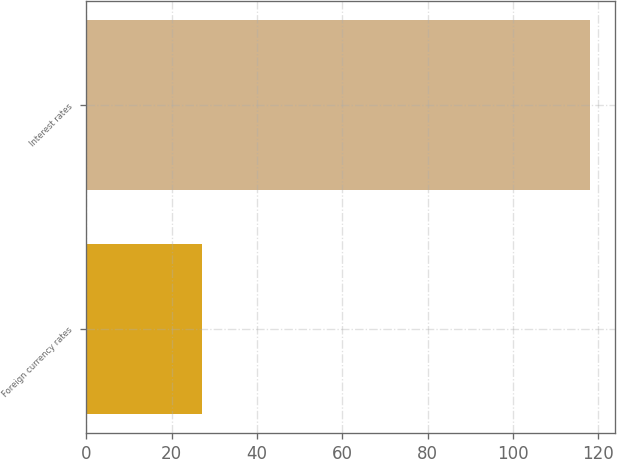Convert chart to OTSL. <chart><loc_0><loc_0><loc_500><loc_500><bar_chart><fcel>Foreign currency rates<fcel>Interest rates<nl><fcel>27<fcel>118<nl></chart> 